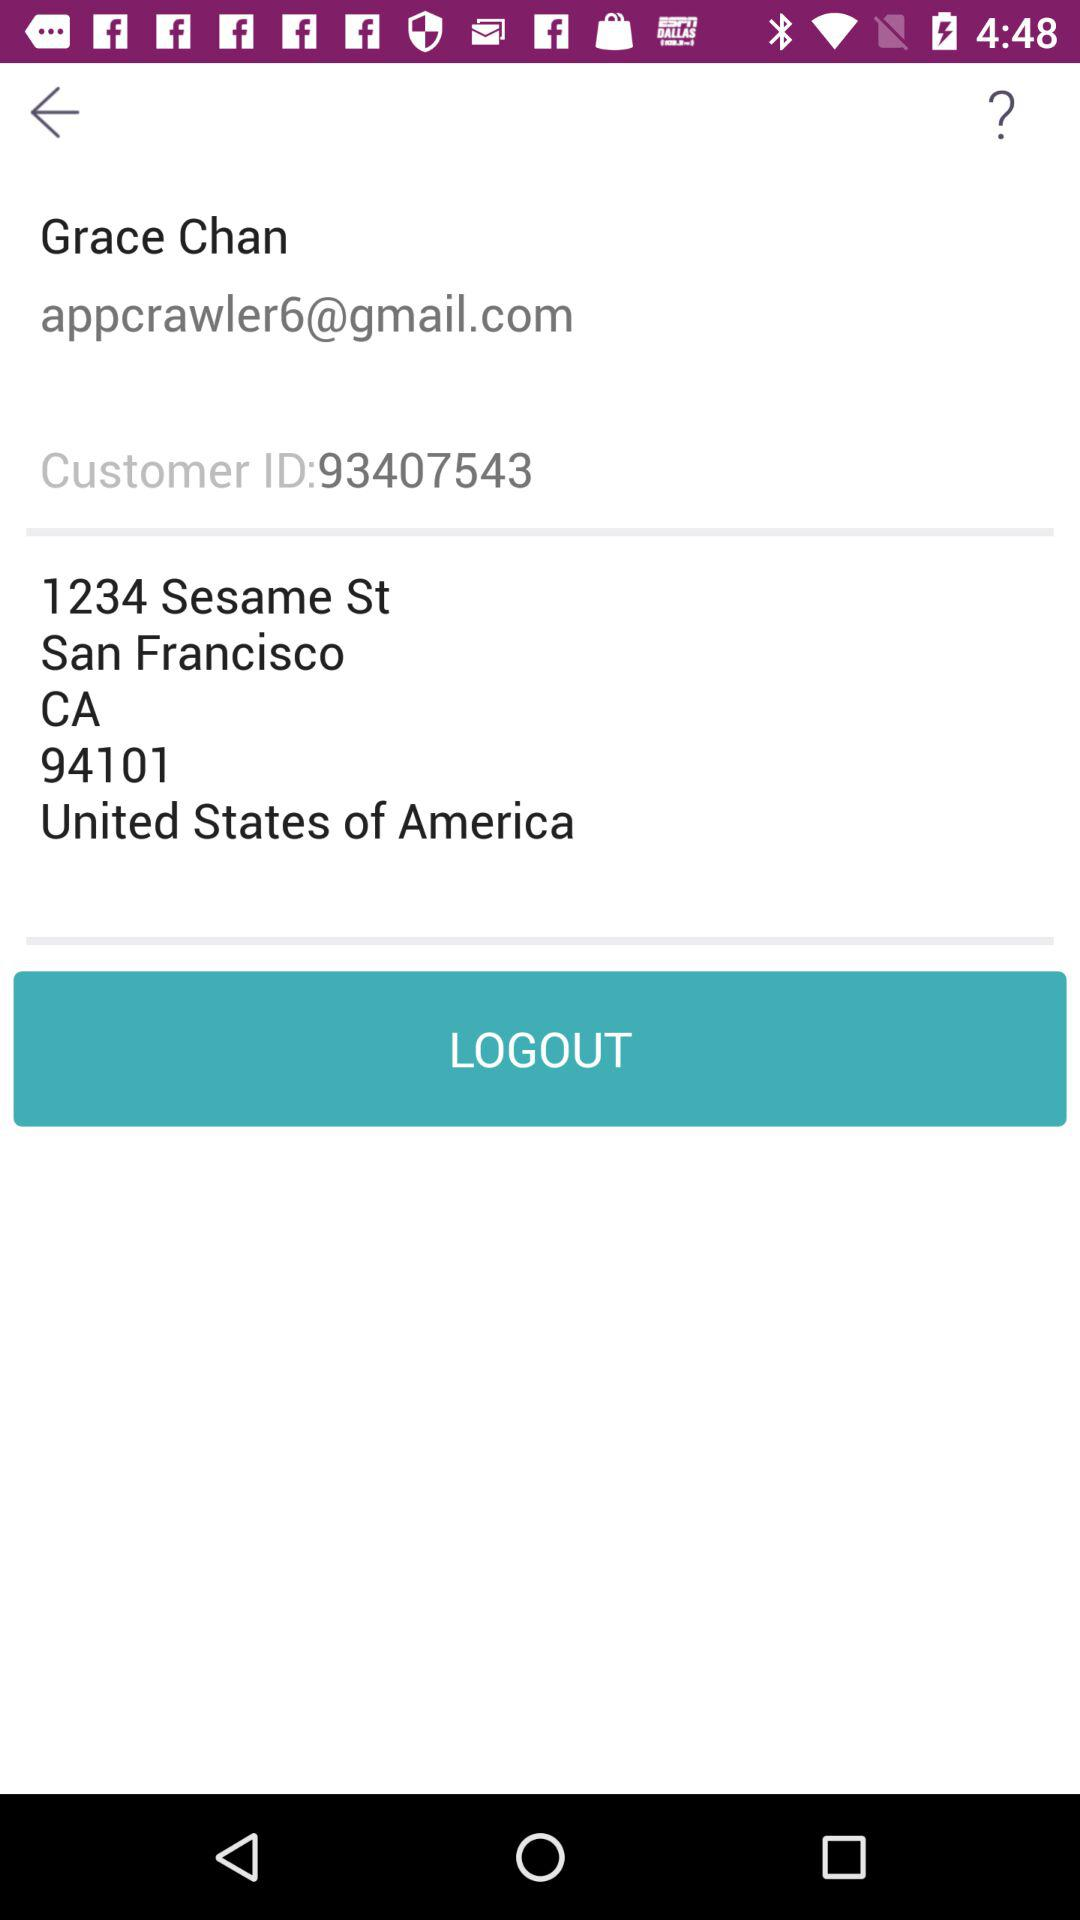What is the name of the user? The name of the user is Grace Chan. 